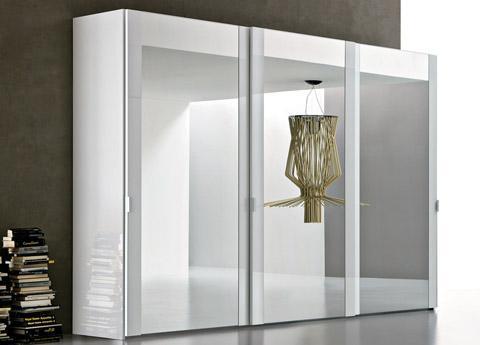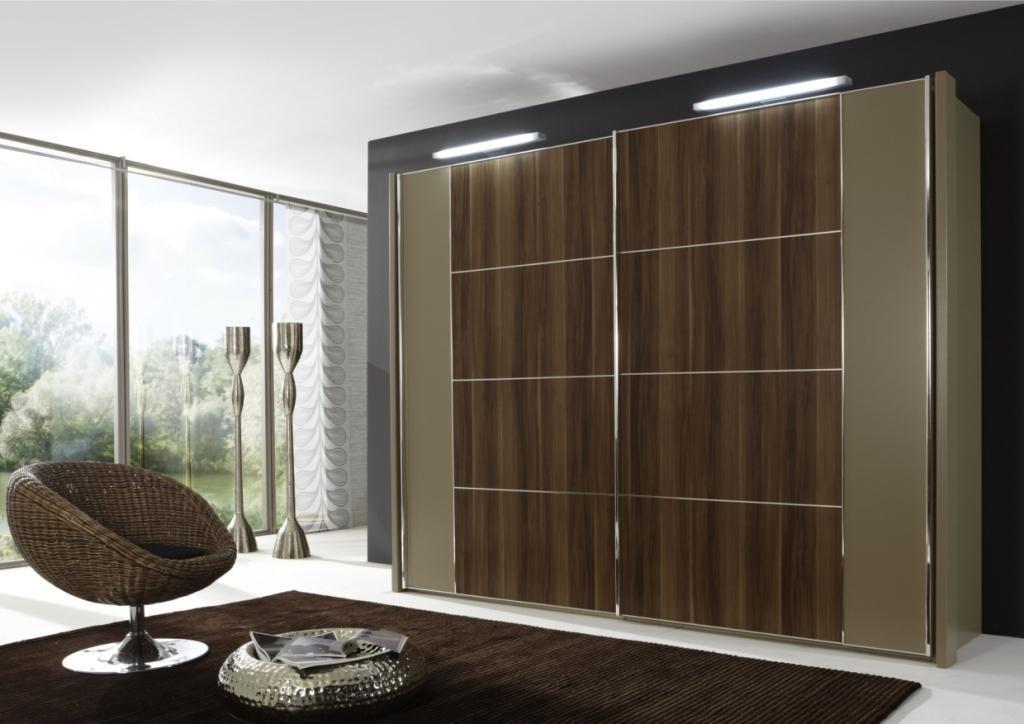The first image is the image on the left, the second image is the image on the right. For the images displayed, is the sentence "One image shows a single white wardrobe, with an open area where clothes hang on the left." factually correct? Answer yes or no. No. The first image is the image on the left, the second image is the image on the right. Given the left and right images, does the statement "Clothing is hanging in the wardrobe in the image on the right." hold true? Answer yes or no. No. 